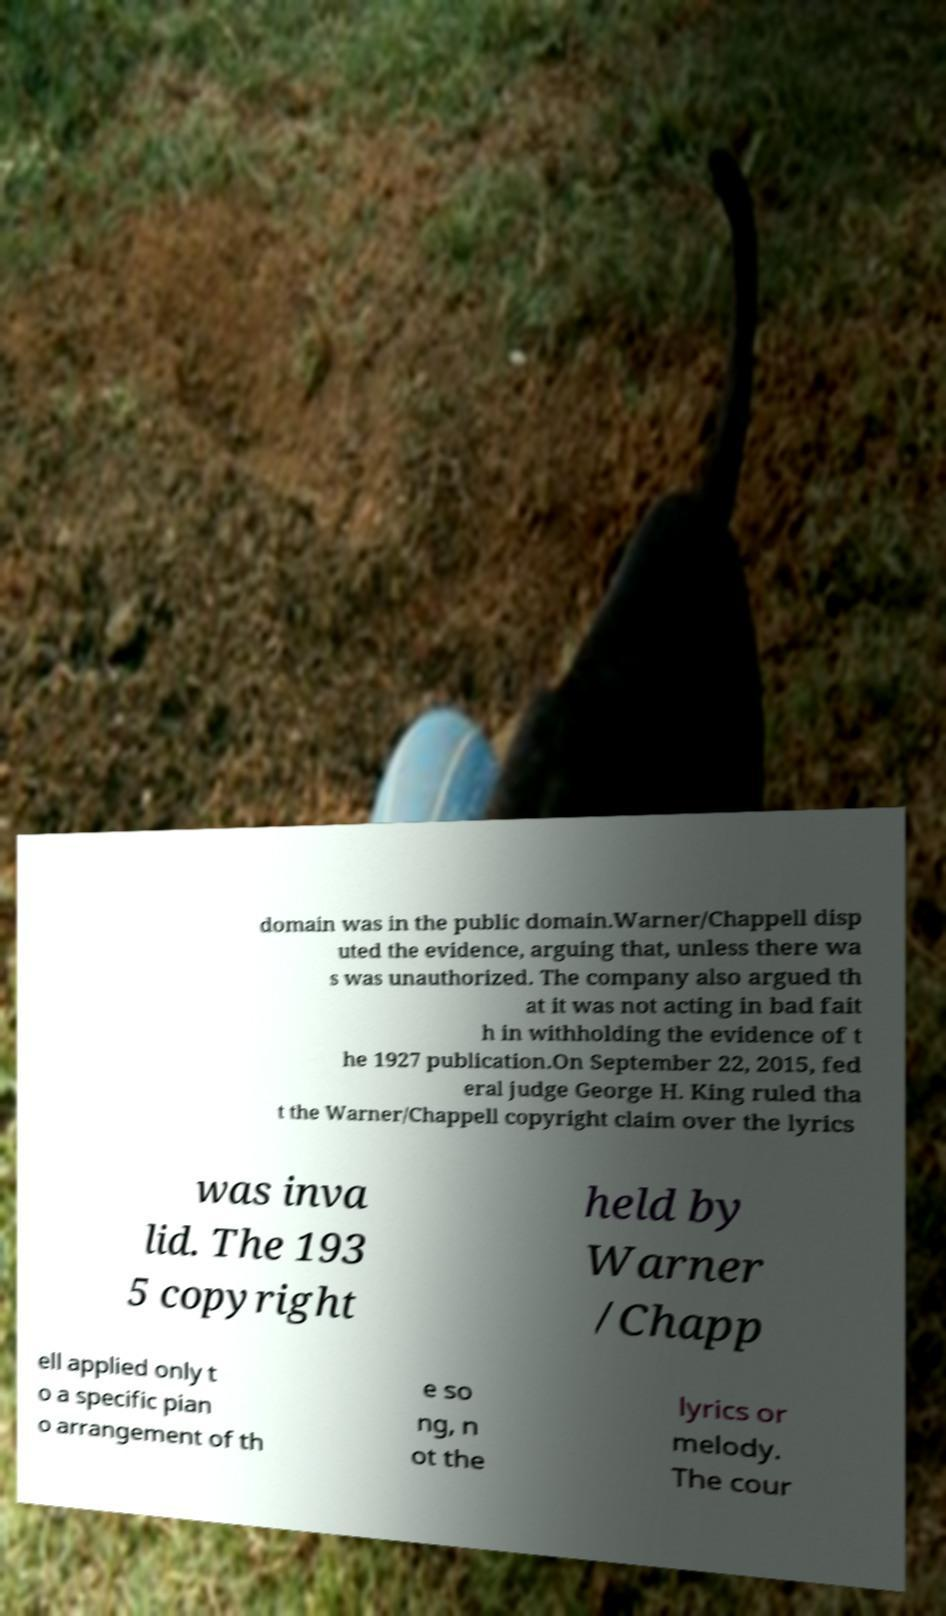There's text embedded in this image that I need extracted. Can you transcribe it verbatim? domain was in the public domain.Warner/Chappell disp uted the evidence, arguing that, unless there wa s was unauthorized. The company also argued th at it was not acting in bad fait h in withholding the evidence of t he 1927 publication.On September 22, 2015, fed eral judge George H. King ruled tha t the Warner/Chappell copyright claim over the lyrics was inva lid. The 193 5 copyright held by Warner /Chapp ell applied only t o a specific pian o arrangement of th e so ng, n ot the lyrics or melody. The cour 